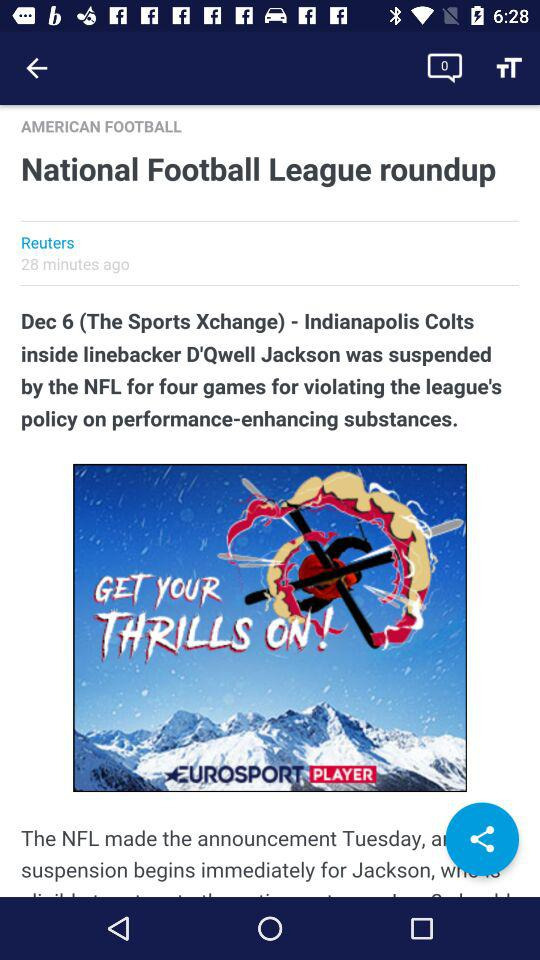What is the author's name?
When the provided information is insufficient, respond with <no answer>. <no answer> 